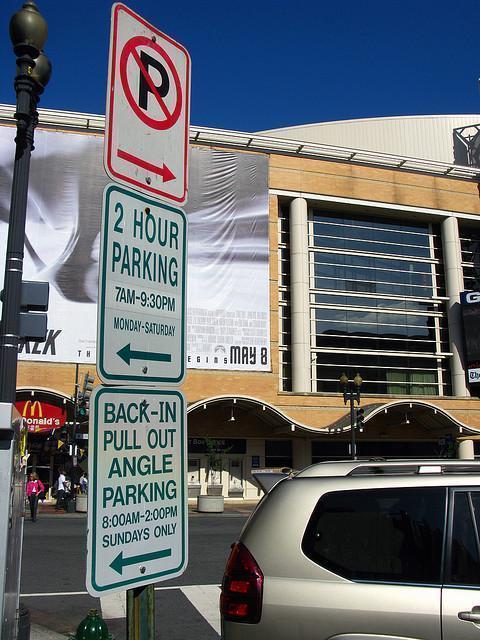The billboard on the building is advertising for which science fiction franchise?
Indicate the correct choice and explain in the format: 'Answer: answer
Rationale: rationale.'
Options: Stargate, dune, star wars, star trek. Answer: star trek.
Rationale: The sign on the building is advertising for a star trek movie. 